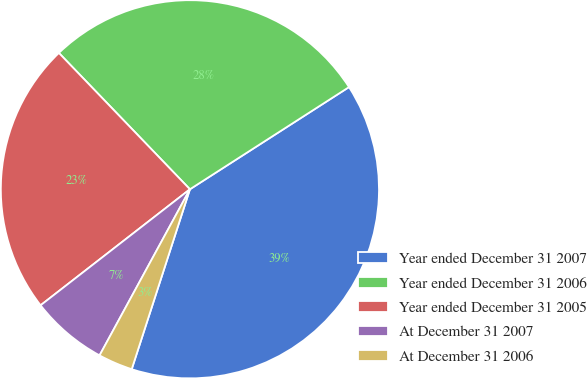Convert chart to OTSL. <chart><loc_0><loc_0><loc_500><loc_500><pie_chart><fcel>Year ended December 31 2007<fcel>Year ended December 31 2006<fcel>Year ended December 31 2005<fcel>At December 31 2007<fcel>At December 31 2006<nl><fcel>39.07%<fcel>28.1%<fcel>23.33%<fcel>6.56%<fcel>2.95%<nl></chart> 